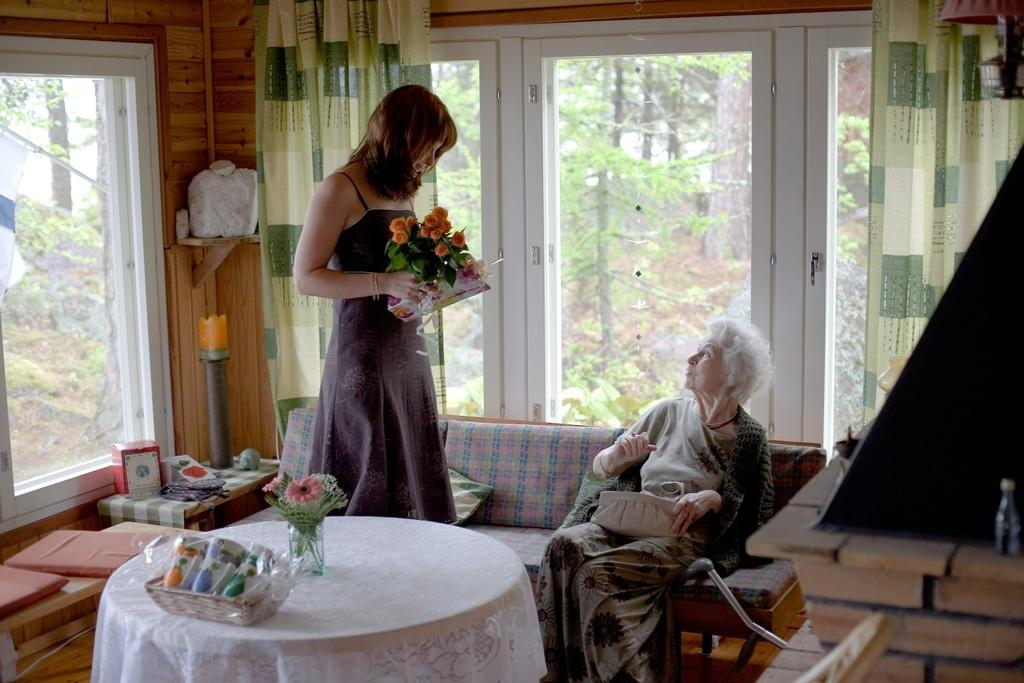What is the woman in the image doing? The woman is standing in the image and holding flowers in her hand. Can you describe the other woman in the image? The other woman is seated on a sofa bed in the image. What can be seen hanging in the background of the image? There are curtains hanging in the image. What piece of furniture is present in the image? There is a table in the image. What type of nut is being used as a decoration on the flag in the image? There is no nut or flag present in the image. Can you describe the goose that is sitting on the table in the image? There is no goose present on the table or anywhere else in the image. 